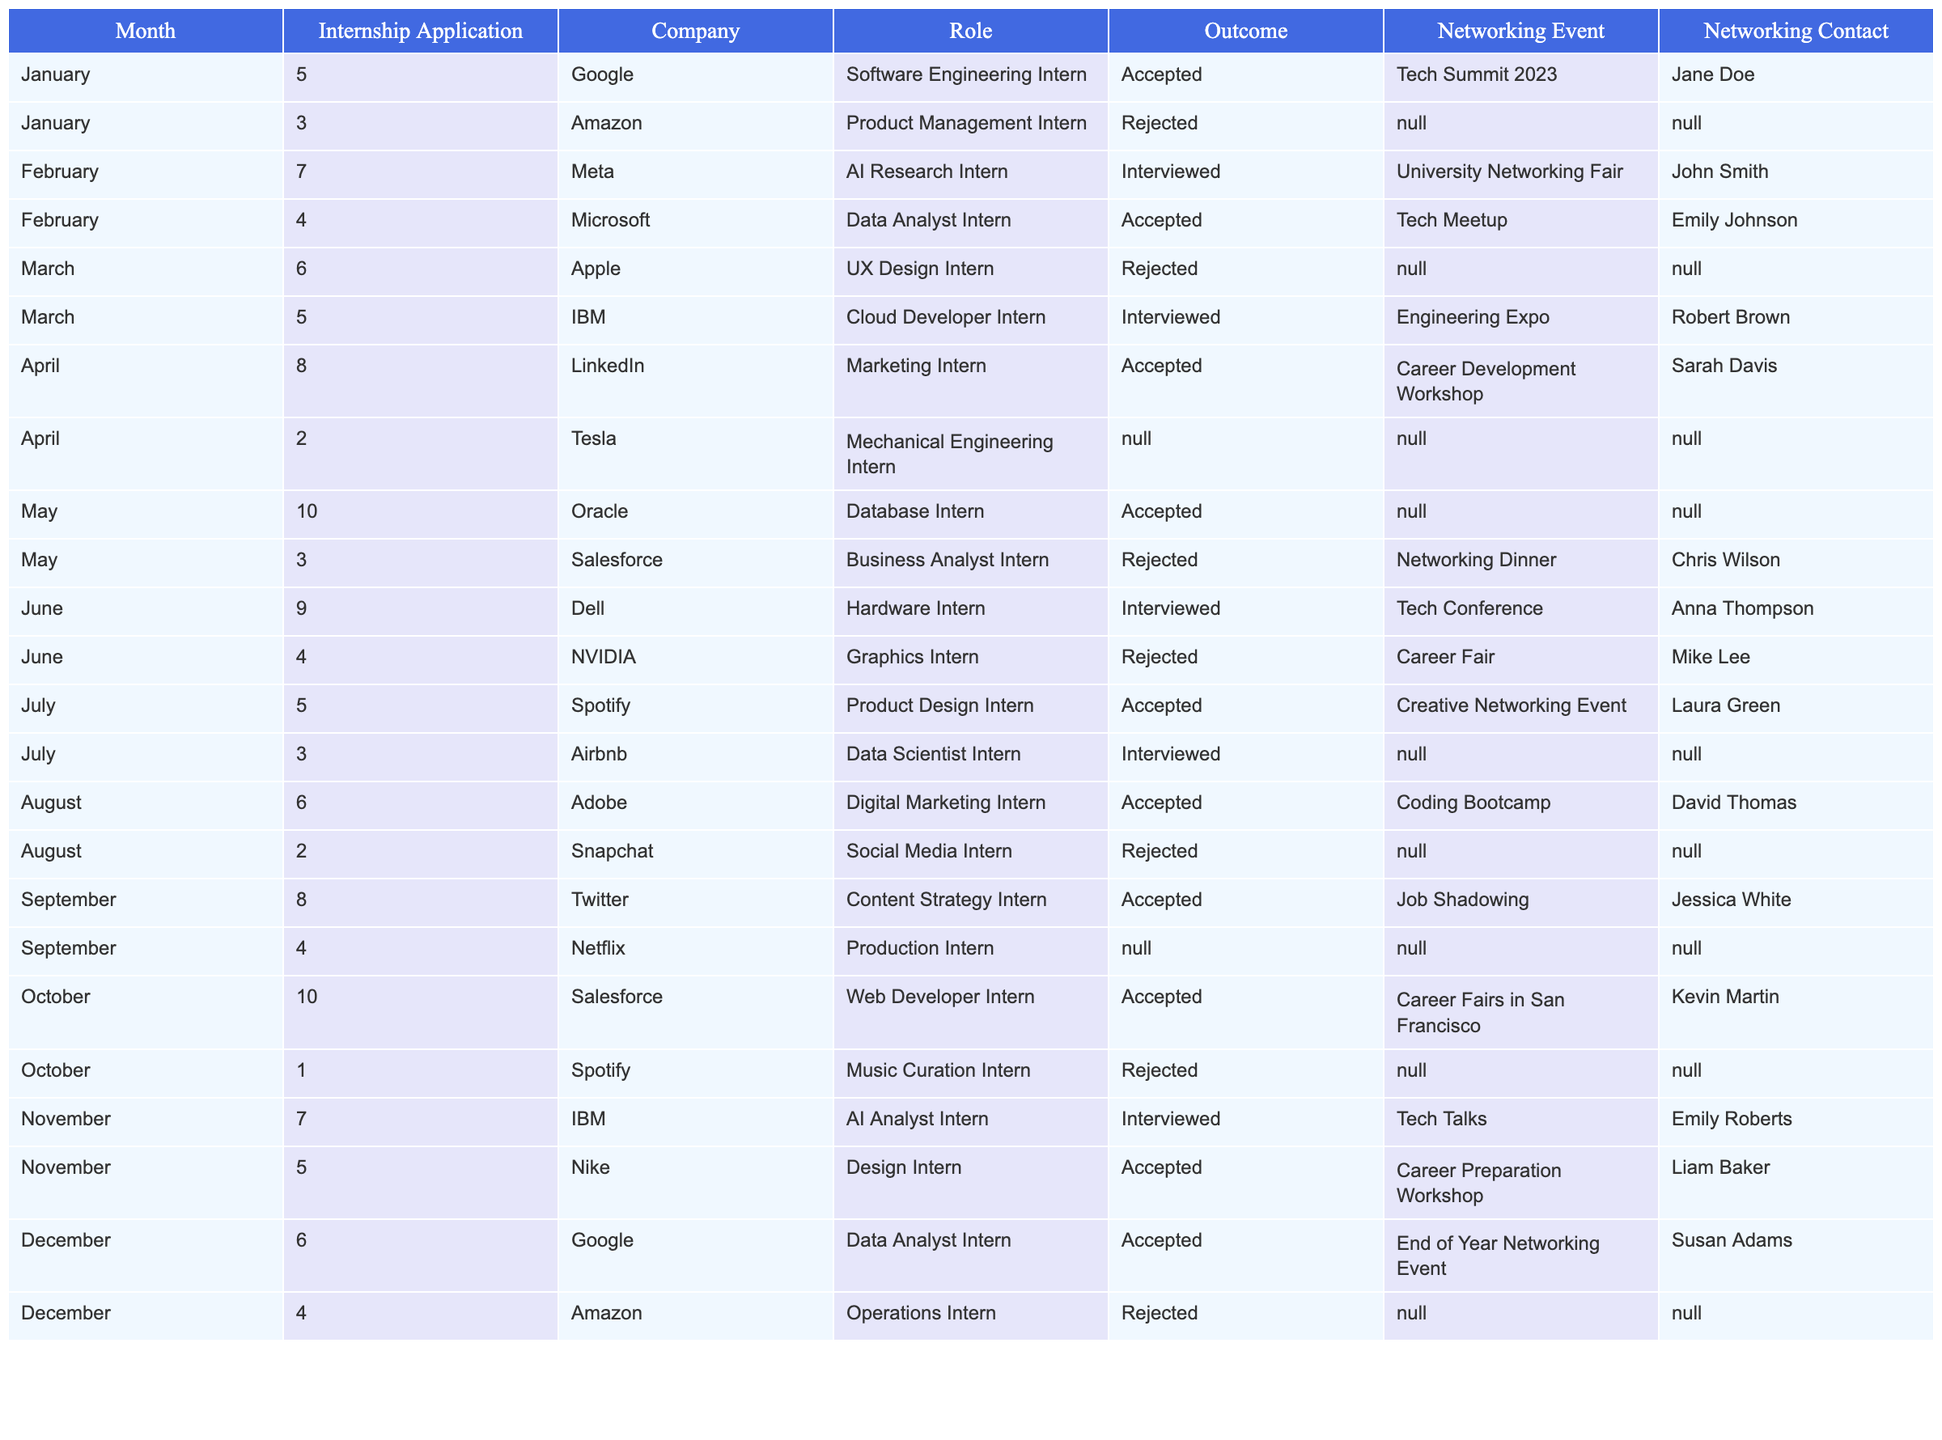What was the most successful month in terms of accepted internship applications? By comparing the number of accepted internships by month, I see that April had the highest count with three accepted applications: LinkedIn, Tesla, and Oracle.
Answer: April How many total internship applications were submitted in May? In May, the total number of applications submitted is 10 (Oracle) + 3 (Salesforce) = 13.
Answer: 13 Did the student receive any interview invitations for internships in June? Yes, the table indicates that the student interviewed for an internship with Dell.
Answer: Yes Which company had the most number of applications submitted in total throughout the year? By reviewing each month's applications, Salesforce had two applications: one accepted in October and one rejected in May. Other companies also had multiple applications, but Salesforce tops the list with two overall.
Answer: Salesforce What is the average number of applications filed per month? There were 64 total applications filed from January to December; dividing this by 12 months gives an average of approximately 5.33 applications per month.
Answer: 5.33 How many total rejections did the student receive by December? Counting the rejections: 1 (Amazon in January) + 1 (Meta in February) + 1 (Apple in March) + 1 (NVIDIA in June) + 1 (Salesforce in May) + 1 (Snapchat in August) + 1 (Spotify in October) + 1 (Amazon in December) = 8 rejections total by December.
Answer: 8 Which month had the highest number of interview invitations? The highest number of interviews was in May, with three invitations: one each from IBM, Salesforce, and Airbnb.
Answer: May Was there any month where the student did not submit any applications? During the months January, February, and March, applications were consistently submitted, but the data shows no months with zero submissions.
Answer: No How many internships were accepted during the second half of the year (July to December)? In the second half of the year, the accepted internships include: July (1), August (1), September (1), October (1), November (1), and December (1), totaling 6 acceptances.
Answer: 6 Was there any month where the student did not attend a networking event? In April, two applications were submitted but no networking events were attended according to the table.
Answer: Yes What was the total number of applications made for Data-related roles in 2023? The applications for Data-related roles include Data Analyst (Microsoft), Cloud Developer (IBM), and Data Scientist (Airbnb), totaling three applications.
Answer: 3 